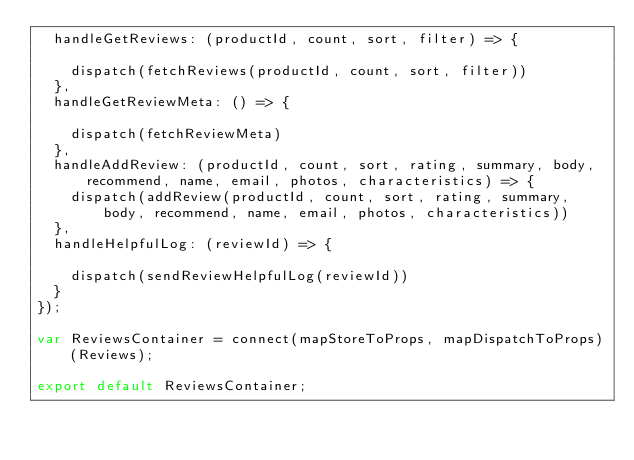Convert code to text. <code><loc_0><loc_0><loc_500><loc_500><_JavaScript_>  handleGetReviews: (productId, count, sort, filter) => {

    dispatch(fetchReviews(productId, count, sort, filter))
  },
  handleGetReviewMeta: () => {

    dispatch(fetchReviewMeta)
  },
  handleAddReview: (productId, count, sort, rating, summary, body, recommend, name, email, photos, characteristics) => {
    dispatch(addReview(productId, count, sort, rating, summary, body, recommend, name, email, photos, characteristics))
  },
  handleHelpfulLog: (reviewId) => {

    dispatch(sendReviewHelpfulLog(reviewId))
  }
});

var ReviewsContainer = connect(mapStoreToProps, mapDispatchToProps)(Reviews);

export default ReviewsContainer;</code> 